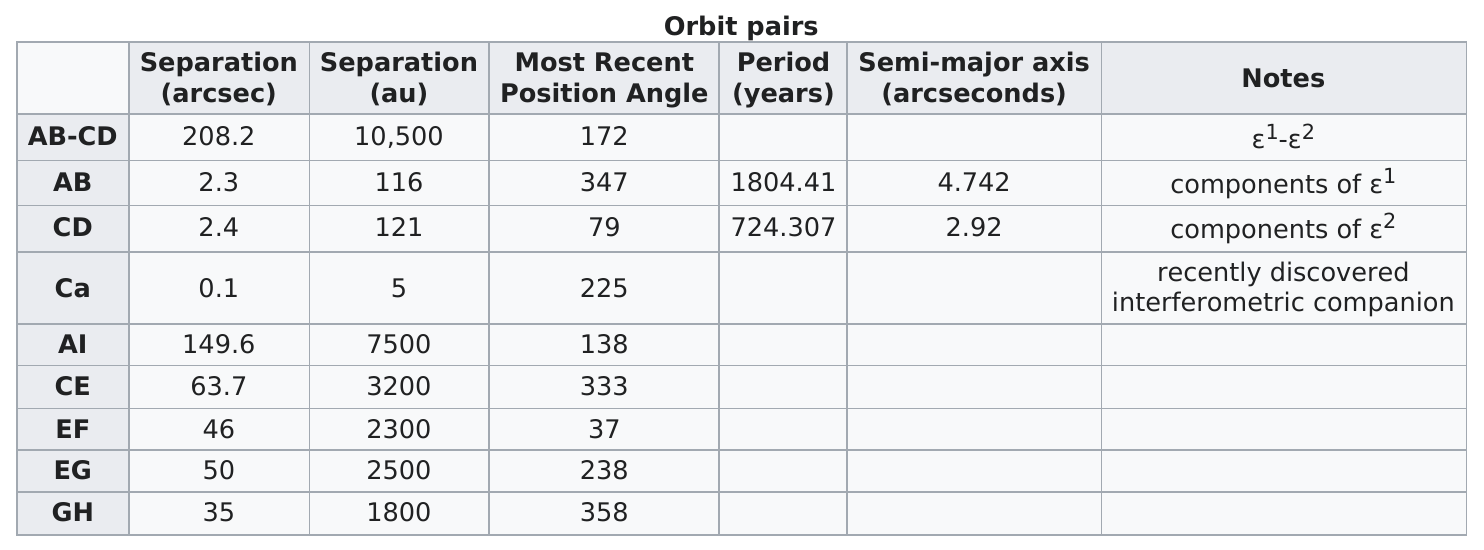Highlight a few significant elements in this photo. Of the orbit pairs, how many have no notes? The orbit pair with a period of 724.307 years is CD. What orbital pair is listed below ef? For example, consider the following orbitals: s, p, d, and f. One example of a celestial body in our solar system that has a separation in arcseconds that is between 2 and 3 is (body of choice). The most recent position angle that was smaller was between 'ca' and 'ce'. 